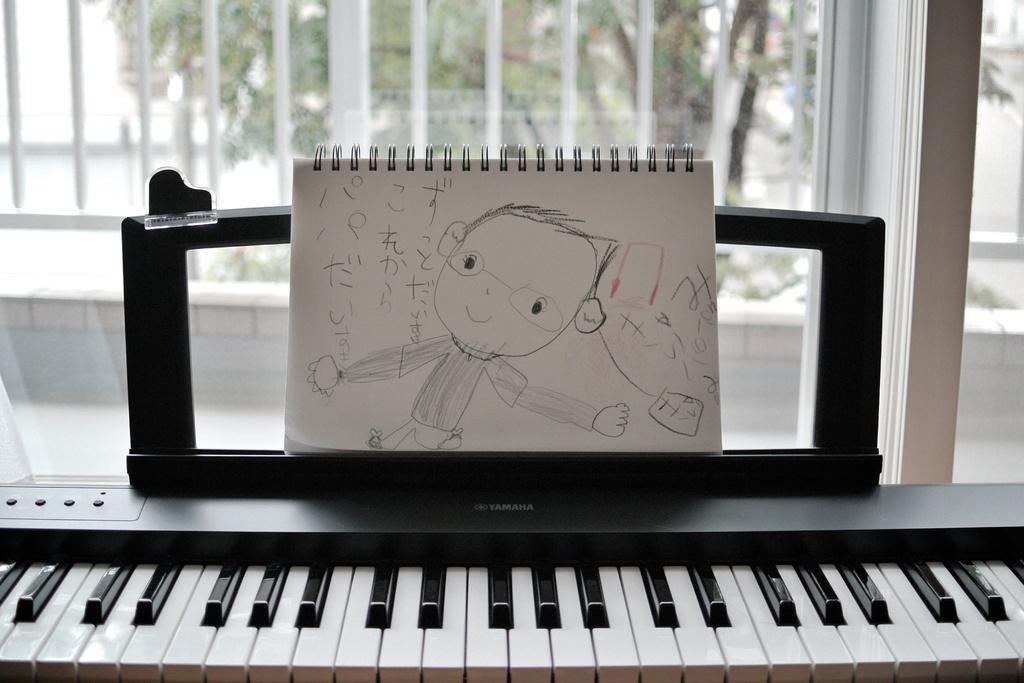Describe this image in one or two sentences. At the bottom of the picture, we see the musical instrument which looks like a keyboard. Beside that, we see a white book in which we can see the drawing. Behind that, we see a glass door and the glass window from which we can see the railing and the trees. 